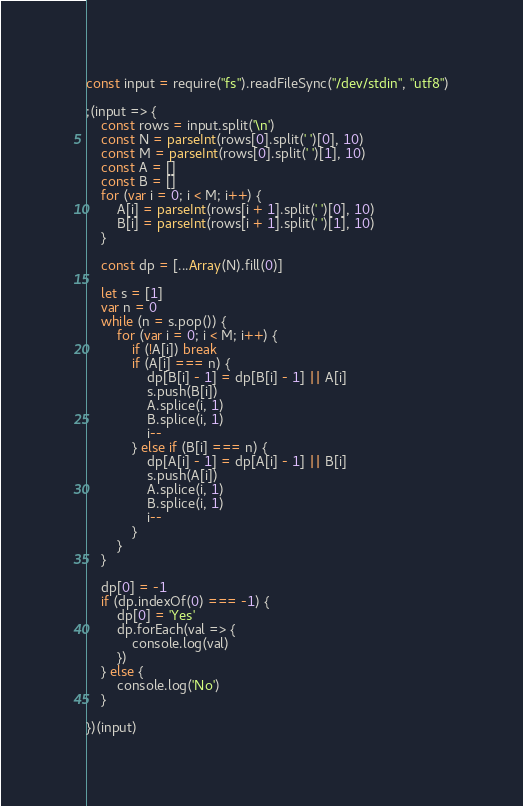Convert code to text. <code><loc_0><loc_0><loc_500><loc_500><_JavaScript_>const input = require("fs").readFileSync("/dev/stdin", "utf8")

;(input => {
    const rows = input.split('\n')
    const N = parseInt(rows[0].split(' ')[0], 10)
    const M = parseInt(rows[0].split(' ')[1], 10)
    const A = []
    const B = []
    for (var i = 0; i < M; i++) {
        A[i] = parseInt(rows[i + 1].split(' ')[0], 10)
        B[i] = parseInt(rows[i + 1].split(' ')[1], 10)
    }

    const dp = [...Array(N).fill(0)]

    let s = [1]
    var n = 0
    while (n = s.pop()) {
        for (var i = 0; i < M; i++) {
            if (!A[i]) break
            if (A[i] === n) {
                dp[B[i] - 1] = dp[B[i] - 1] || A[i]
                s.push(B[i])
                A.splice(i, 1)
                B.splice(i, 1)
                i--
            } else if (B[i] === n) {
                dp[A[i] - 1] = dp[A[i] - 1] || B[i]
                s.push(A[i])
                A.splice(i, 1)
                B.splice(i, 1)
                i--
            }
        }
    }

    dp[0] = -1
    if (dp.indexOf(0) === -1) {
        dp[0] = 'Yes'
        dp.forEach(val => {
            console.log(val)
        })
    } else {
        console.log('No')
    }

})(input)
</code> 